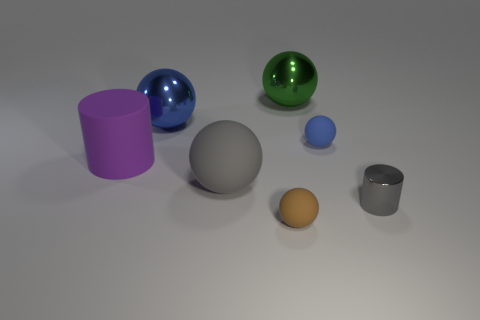Subtract all big gray spheres. How many spheres are left? 4 Subtract all green spheres. How many spheres are left? 4 Subtract all red spheres. Subtract all gray blocks. How many spheres are left? 5 Add 1 tiny gray cylinders. How many objects exist? 8 Subtract all balls. How many objects are left? 2 Add 4 rubber cylinders. How many rubber cylinders exist? 5 Subtract 0 yellow cylinders. How many objects are left? 7 Subtract all large green shiny spheres. Subtract all big green spheres. How many objects are left? 5 Add 4 blue balls. How many blue balls are left? 6 